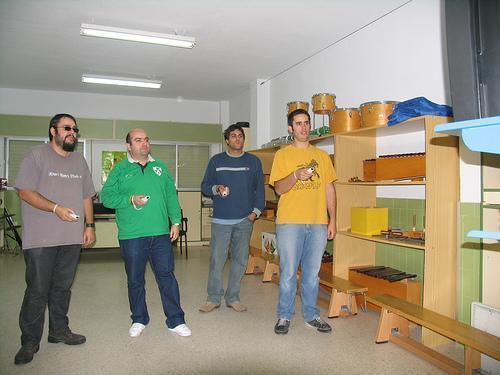How many people are shown?
Give a very brief answer. 4. How many lights are on the ceiling?
Give a very brief answer. 2. How many people in the picture are wearing the same yellow t-shirt?
Give a very brief answer. 1. How many benches can you see?
Give a very brief answer. 2. How many people can you see?
Give a very brief answer. 4. 